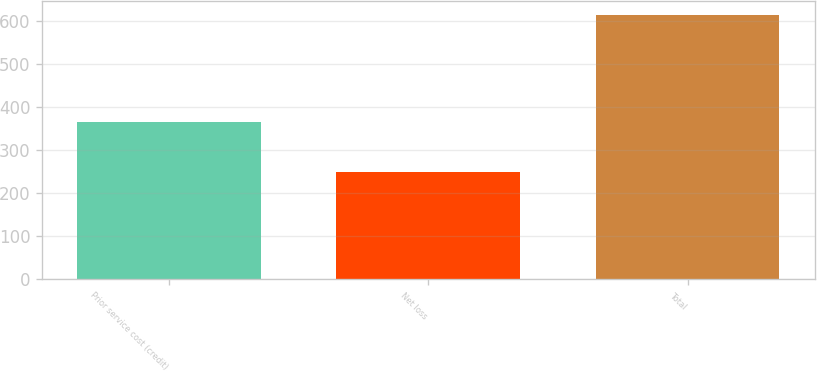Convert chart. <chart><loc_0><loc_0><loc_500><loc_500><bar_chart><fcel>Prior service cost (credit)<fcel>Net loss<fcel>Total<nl><fcel>366<fcel>249<fcel>615<nl></chart> 